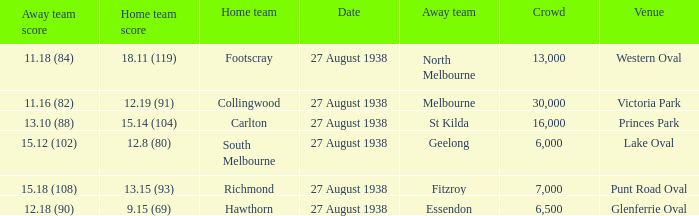Which home team had the away team score 15.18 (108) against them? 13.15 (93). 